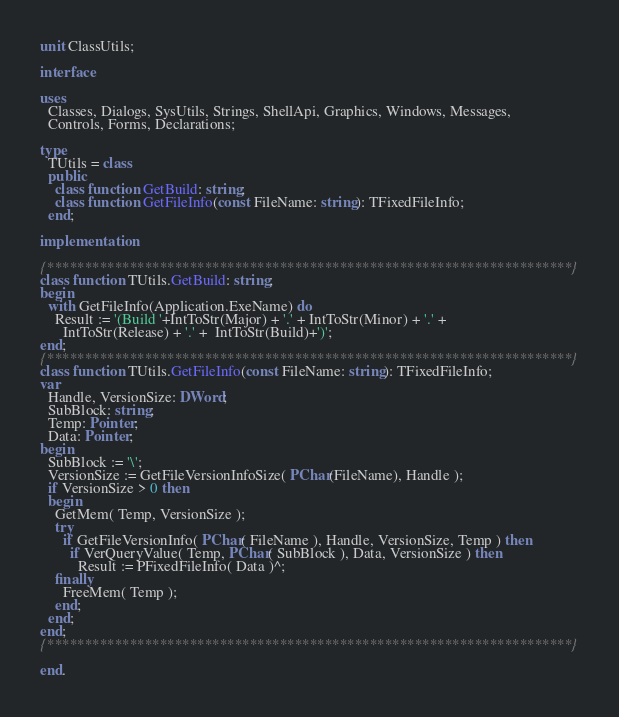<code> <loc_0><loc_0><loc_500><loc_500><_Pascal_>unit ClassUtils;

interface

uses
  Classes, Dialogs, SysUtils, Strings, ShellApi, Graphics, Windows, Messages,
  Controls, Forms, Declarations;

type
  TUtils = class
  public
    class function GetBuild: string;
    class function GetFileInfo(const FileName: string): TFixedFileInfo;
  end;

implementation

{**********************************************************************}
class function TUtils.GetBuild: string;
begin
  with GetFileInfo(Application.ExeName) do
    Result := '(Build '+IntToStr(Major) + '.' + IntToStr(Minor) + '.' +
      IntToStr(Release) + '.' +  IntToStr(Build)+')';
end;
{**********************************************************************}
class function TUtils.GetFileInfo(const FileName: string): TFixedFileInfo;
var
  Handle, VersionSize: DWord;
  SubBlock: string;
  Temp: Pointer;
  Data: Pointer;
begin
  SubBlock := '\';
  VersionSize := GetFileVersionInfoSize( PChar(FileName), Handle );
  if VersionSize > 0 then
  begin
    GetMem( Temp, VersionSize );
    try
      if GetFileVersionInfo( PChar( FileName ), Handle, VersionSize, Temp ) then
        if VerQueryValue( Temp, PChar( SubBlock ), Data, VersionSize ) then
          Result := PFixedFileInfo( Data )^;
    finally
      FreeMem( Temp );
    end;
  end;
end;
{**********************************************************************}

end.

</code> 